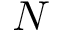<formula> <loc_0><loc_0><loc_500><loc_500>N</formula> 